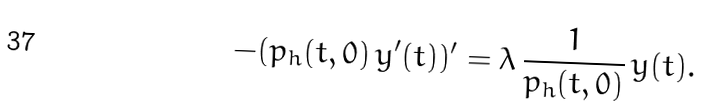<formula> <loc_0><loc_0><loc_500><loc_500>- ( p _ { h } ( t , 0 ) \, y ^ { \prime } ( t ) ) ^ { \prime } = \lambda \, \frac { 1 } { p _ { h } ( t , 0 ) } \, y ( t ) .</formula> 